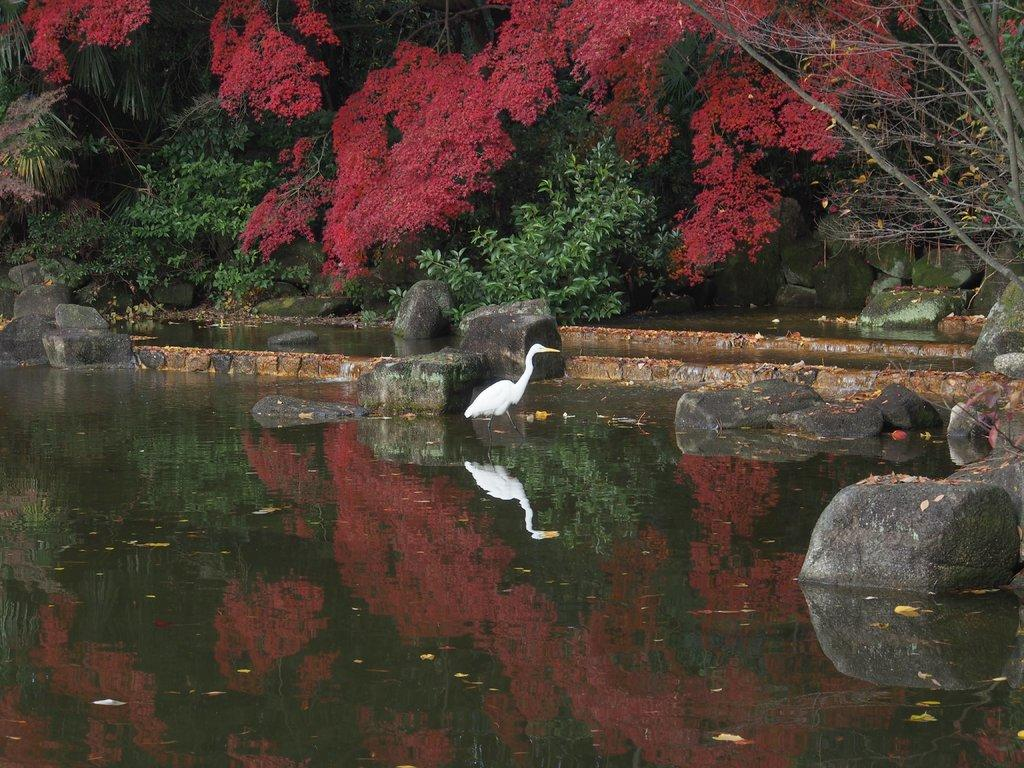What is: What is the primary element in the image? There is water in the image. What other objects can be seen in the image? There are stones and a bird visible in the image. What can be seen in the background of the image? There are flowers and trees in the background of the image. What type of cake is being held by the bird in the image? There is no cake present in the image; it features water, stones, a bird, flowers, and trees. How many wheels can be seen in the image? There are no wheels present in the image. 